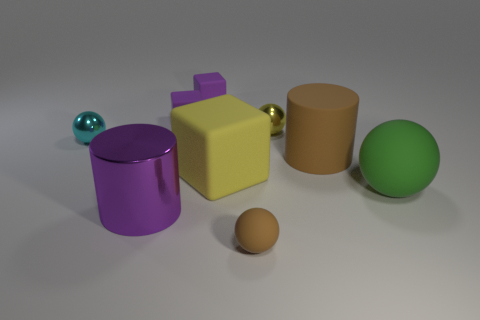How many tiny balls are the same color as the large matte block?
Offer a terse response. 1. What is the material of the yellow thing left of the small sphere that is to the right of the brown thing in front of the yellow matte cube?
Provide a short and direct response. Rubber. What number of purple things are cubes or big objects?
Provide a succinct answer. 3. How big is the sphere that is to the right of the metallic sphere that is to the right of the rubber ball left of the large rubber ball?
Make the answer very short. Large. What size is the other shiny object that is the same shape as the cyan metallic thing?
Make the answer very short. Small. What number of large objects are purple cylinders or yellow rubber cylinders?
Make the answer very short. 1. Does the small cyan ball to the left of the big yellow rubber block have the same material as the purple object that is in front of the yellow rubber block?
Give a very brief answer. Yes. What is the material of the brown thing that is behind the big rubber block?
Keep it short and to the point. Rubber. What number of shiny things are either big gray balls or cyan things?
Keep it short and to the point. 1. What color is the small object that is in front of the matte object on the right side of the large brown rubber cylinder?
Keep it short and to the point. Brown. 